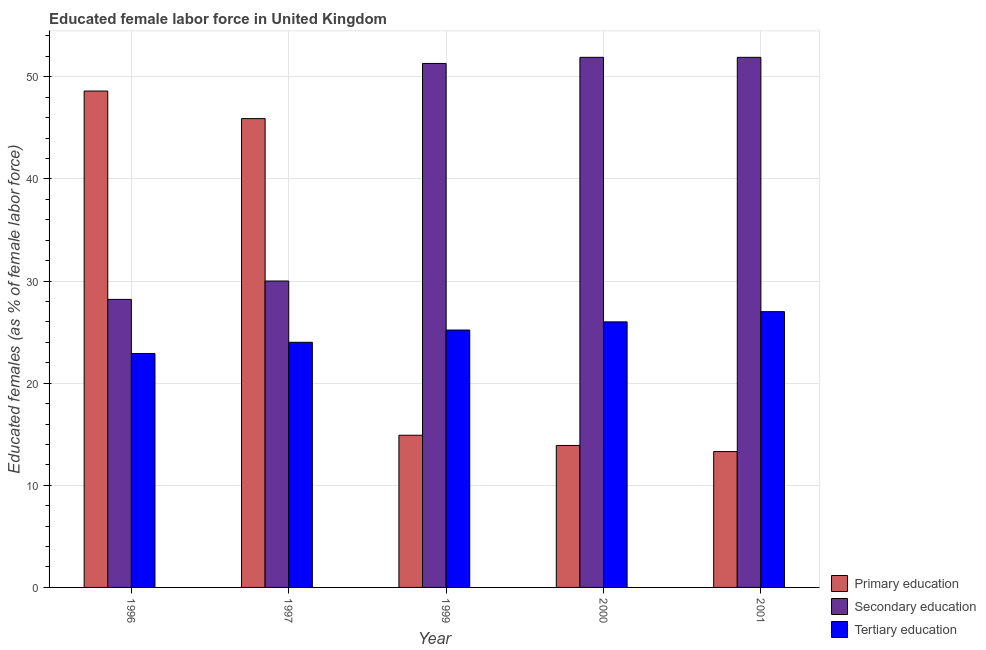Are the number of bars per tick equal to the number of legend labels?
Your answer should be compact. Yes. How many bars are there on the 4th tick from the right?
Ensure brevity in your answer.  3. In how many cases, is the number of bars for a given year not equal to the number of legend labels?
Keep it short and to the point. 0. What is the percentage of female labor force who received secondary education in 2000?
Offer a terse response. 51.9. Across all years, what is the maximum percentage of female labor force who received secondary education?
Keep it short and to the point. 51.9. Across all years, what is the minimum percentage of female labor force who received tertiary education?
Your response must be concise. 22.9. In which year was the percentage of female labor force who received tertiary education maximum?
Give a very brief answer. 2001. What is the total percentage of female labor force who received secondary education in the graph?
Give a very brief answer. 213.3. What is the difference between the percentage of female labor force who received secondary education in 1999 and that in 2000?
Your answer should be compact. -0.6. What is the difference between the percentage of female labor force who received tertiary education in 1996 and the percentage of female labor force who received primary education in 2000?
Make the answer very short. -3.1. What is the average percentage of female labor force who received primary education per year?
Offer a terse response. 27.32. In the year 1997, what is the difference between the percentage of female labor force who received secondary education and percentage of female labor force who received tertiary education?
Your response must be concise. 0. In how many years, is the percentage of female labor force who received primary education greater than 16 %?
Offer a very short reply. 2. What is the ratio of the percentage of female labor force who received tertiary education in 1997 to that in 1999?
Provide a succinct answer. 0.95. Is the percentage of female labor force who received primary education in 2000 less than that in 2001?
Ensure brevity in your answer.  No. What is the difference between the highest and the second highest percentage of female labor force who received secondary education?
Provide a succinct answer. 0. What is the difference between the highest and the lowest percentage of female labor force who received primary education?
Offer a terse response. 35.3. What does the 2nd bar from the left in 2000 represents?
Your answer should be compact. Secondary education. What does the 2nd bar from the right in 2000 represents?
Your answer should be compact. Secondary education. What is the difference between two consecutive major ticks on the Y-axis?
Your answer should be compact. 10. Are the values on the major ticks of Y-axis written in scientific E-notation?
Make the answer very short. No. Does the graph contain grids?
Provide a succinct answer. Yes. How many legend labels are there?
Give a very brief answer. 3. How are the legend labels stacked?
Offer a very short reply. Vertical. What is the title of the graph?
Give a very brief answer. Educated female labor force in United Kingdom. Does "Errors" appear as one of the legend labels in the graph?
Keep it short and to the point. No. What is the label or title of the X-axis?
Provide a short and direct response. Year. What is the label or title of the Y-axis?
Ensure brevity in your answer.  Educated females (as % of female labor force). What is the Educated females (as % of female labor force) in Primary education in 1996?
Offer a terse response. 48.6. What is the Educated females (as % of female labor force) in Secondary education in 1996?
Provide a short and direct response. 28.2. What is the Educated females (as % of female labor force) in Tertiary education in 1996?
Make the answer very short. 22.9. What is the Educated females (as % of female labor force) in Primary education in 1997?
Offer a terse response. 45.9. What is the Educated females (as % of female labor force) in Secondary education in 1997?
Ensure brevity in your answer.  30. What is the Educated females (as % of female labor force) in Primary education in 1999?
Make the answer very short. 14.9. What is the Educated females (as % of female labor force) in Secondary education in 1999?
Make the answer very short. 51.3. What is the Educated females (as % of female labor force) of Tertiary education in 1999?
Ensure brevity in your answer.  25.2. What is the Educated females (as % of female labor force) in Primary education in 2000?
Give a very brief answer. 13.9. What is the Educated females (as % of female labor force) in Secondary education in 2000?
Your answer should be very brief. 51.9. What is the Educated females (as % of female labor force) in Tertiary education in 2000?
Keep it short and to the point. 26. What is the Educated females (as % of female labor force) in Primary education in 2001?
Provide a succinct answer. 13.3. What is the Educated females (as % of female labor force) of Secondary education in 2001?
Your answer should be very brief. 51.9. Across all years, what is the maximum Educated females (as % of female labor force) in Primary education?
Make the answer very short. 48.6. Across all years, what is the maximum Educated females (as % of female labor force) of Secondary education?
Ensure brevity in your answer.  51.9. Across all years, what is the maximum Educated females (as % of female labor force) of Tertiary education?
Ensure brevity in your answer.  27. Across all years, what is the minimum Educated females (as % of female labor force) in Primary education?
Ensure brevity in your answer.  13.3. Across all years, what is the minimum Educated females (as % of female labor force) in Secondary education?
Provide a short and direct response. 28.2. Across all years, what is the minimum Educated females (as % of female labor force) in Tertiary education?
Provide a succinct answer. 22.9. What is the total Educated females (as % of female labor force) of Primary education in the graph?
Offer a terse response. 136.6. What is the total Educated females (as % of female labor force) in Secondary education in the graph?
Your answer should be compact. 213.3. What is the total Educated females (as % of female labor force) of Tertiary education in the graph?
Offer a terse response. 125.1. What is the difference between the Educated females (as % of female labor force) in Tertiary education in 1996 and that in 1997?
Offer a very short reply. -1.1. What is the difference between the Educated females (as % of female labor force) of Primary education in 1996 and that in 1999?
Offer a terse response. 33.7. What is the difference between the Educated females (as % of female labor force) of Secondary education in 1996 and that in 1999?
Make the answer very short. -23.1. What is the difference between the Educated females (as % of female labor force) of Primary education in 1996 and that in 2000?
Give a very brief answer. 34.7. What is the difference between the Educated females (as % of female labor force) in Secondary education in 1996 and that in 2000?
Offer a terse response. -23.7. What is the difference between the Educated females (as % of female labor force) of Tertiary education in 1996 and that in 2000?
Keep it short and to the point. -3.1. What is the difference between the Educated females (as % of female labor force) of Primary education in 1996 and that in 2001?
Your answer should be very brief. 35.3. What is the difference between the Educated females (as % of female labor force) of Secondary education in 1996 and that in 2001?
Keep it short and to the point. -23.7. What is the difference between the Educated females (as % of female labor force) of Tertiary education in 1996 and that in 2001?
Offer a very short reply. -4.1. What is the difference between the Educated females (as % of female labor force) of Secondary education in 1997 and that in 1999?
Make the answer very short. -21.3. What is the difference between the Educated females (as % of female labor force) of Primary education in 1997 and that in 2000?
Provide a short and direct response. 32. What is the difference between the Educated females (as % of female labor force) in Secondary education in 1997 and that in 2000?
Your answer should be very brief. -21.9. What is the difference between the Educated females (as % of female labor force) in Tertiary education in 1997 and that in 2000?
Ensure brevity in your answer.  -2. What is the difference between the Educated females (as % of female labor force) in Primary education in 1997 and that in 2001?
Provide a short and direct response. 32.6. What is the difference between the Educated females (as % of female labor force) in Secondary education in 1997 and that in 2001?
Ensure brevity in your answer.  -21.9. What is the difference between the Educated females (as % of female labor force) in Primary education in 1999 and that in 2000?
Keep it short and to the point. 1. What is the difference between the Educated females (as % of female labor force) of Secondary education in 1999 and that in 2000?
Your answer should be compact. -0.6. What is the difference between the Educated females (as % of female labor force) in Tertiary education in 1999 and that in 2000?
Give a very brief answer. -0.8. What is the difference between the Educated females (as % of female labor force) of Primary education in 1999 and that in 2001?
Give a very brief answer. 1.6. What is the difference between the Educated females (as % of female labor force) in Tertiary education in 1999 and that in 2001?
Provide a succinct answer. -1.8. What is the difference between the Educated females (as % of female labor force) in Primary education in 2000 and that in 2001?
Provide a succinct answer. 0.6. What is the difference between the Educated females (as % of female labor force) of Tertiary education in 2000 and that in 2001?
Provide a succinct answer. -1. What is the difference between the Educated females (as % of female labor force) of Primary education in 1996 and the Educated females (as % of female labor force) of Secondary education in 1997?
Provide a short and direct response. 18.6. What is the difference between the Educated females (as % of female labor force) of Primary education in 1996 and the Educated females (as % of female labor force) of Tertiary education in 1997?
Keep it short and to the point. 24.6. What is the difference between the Educated females (as % of female labor force) in Secondary education in 1996 and the Educated females (as % of female labor force) in Tertiary education in 1997?
Give a very brief answer. 4.2. What is the difference between the Educated females (as % of female labor force) in Primary education in 1996 and the Educated females (as % of female labor force) in Tertiary education in 1999?
Give a very brief answer. 23.4. What is the difference between the Educated females (as % of female labor force) in Secondary education in 1996 and the Educated females (as % of female labor force) in Tertiary education in 1999?
Offer a terse response. 3. What is the difference between the Educated females (as % of female labor force) of Primary education in 1996 and the Educated females (as % of female labor force) of Secondary education in 2000?
Provide a succinct answer. -3.3. What is the difference between the Educated females (as % of female labor force) in Primary education in 1996 and the Educated females (as % of female labor force) in Tertiary education in 2000?
Your response must be concise. 22.6. What is the difference between the Educated females (as % of female labor force) of Secondary education in 1996 and the Educated females (as % of female labor force) of Tertiary education in 2000?
Offer a very short reply. 2.2. What is the difference between the Educated females (as % of female labor force) in Primary education in 1996 and the Educated females (as % of female labor force) in Secondary education in 2001?
Your response must be concise. -3.3. What is the difference between the Educated females (as % of female labor force) in Primary education in 1996 and the Educated females (as % of female labor force) in Tertiary education in 2001?
Your answer should be compact. 21.6. What is the difference between the Educated females (as % of female labor force) in Secondary education in 1996 and the Educated females (as % of female labor force) in Tertiary education in 2001?
Ensure brevity in your answer.  1.2. What is the difference between the Educated females (as % of female labor force) of Primary education in 1997 and the Educated females (as % of female labor force) of Secondary education in 1999?
Provide a succinct answer. -5.4. What is the difference between the Educated females (as % of female labor force) in Primary education in 1997 and the Educated females (as % of female labor force) in Tertiary education in 1999?
Provide a short and direct response. 20.7. What is the difference between the Educated females (as % of female labor force) in Secondary education in 1997 and the Educated females (as % of female labor force) in Tertiary education in 2001?
Offer a very short reply. 3. What is the difference between the Educated females (as % of female labor force) in Primary education in 1999 and the Educated females (as % of female labor force) in Secondary education in 2000?
Give a very brief answer. -37. What is the difference between the Educated females (as % of female labor force) in Primary education in 1999 and the Educated females (as % of female labor force) in Tertiary education in 2000?
Provide a succinct answer. -11.1. What is the difference between the Educated females (as % of female labor force) of Secondary education in 1999 and the Educated females (as % of female labor force) of Tertiary education in 2000?
Your response must be concise. 25.3. What is the difference between the Educated females (as % of female labor force) in Primary education in 1999 and the Educated females (as % of female labor force) in Secondary education in 2001?
Your answer should be compact. -37. What is the difference between the Educated females (as % of female labor force) of Secondary education in 1999 and the Educated females (as % of female labor force) of Tertiary education in 2001?
Provide a short and direct response. 24.3. What is the difference between the Educated females (as % of female labor force) in Primary education in 2000 and the Educated females (as % of female labor force) in Secondary education in 2001?
Provide a succinct answer. -38. What is the difference between the Educated females (as % of female labor force) of Secondary education in 2000 and the Educated females (as % of female labor force) of Tertiary education in 2001?
Make the answer very short. 24.9. What is the average Educated females (as % of female labor force) of Primary education per year?
Offer a terse response. 27.32. What is the average Educated females (as % of female labor force) in Secondary education per year?
Provide a short and direct response. 42.66. What is the average Educated females (as % of female labor force) in Tertiary education per year?
Your answer should be compact. 25.02. In the year 1996, what is the difference between the Educated females (as % of female labor force) in Primary education and Educated females (as % of female labor force) in Secondary education?
Your response must be concise. 20.4. In the year 1996, what is the difference between the Educated females (as % of female labor force) of Primary education and Educated females (as % of female labor force) of Tertiary education?
Your response must be concise. 25.7. In the year 1997, what is the difference between the Educated females (as % of female labor force) in Primary education and Educated females (as % of female labor force) in Secondary education?
Provide a succinct answer. 15.9. In the year 1997, what is the difference between the Educated females (as % of female labor force) in Primary education and Educated females (as % of female labor force) in Tertiary education?
Your answer should be very brief. 21.9. In the year 1999, what is the difference between the Educated females (as % of female labor force) in Primary education and Educated females (as % of female labor force) in Secondary education?
Ensure brevity in your answer.  -36.4. In the year 1999, what is the difference between the Educated females (as % of female labor force) in Secondary education and Educated females (as % of female labor force) in Tertiary education?
Provide a succinct answer. 26.1. In the year 2000, what is the difference between the Educated females (as % of female labor force) in Primary education and Educated females (as % of female labor force) in Secondary education?
Provide a succinct answer. -38. In the year 2000, what is the difference between the Educated females (as % of female labor force) in Secondary education and Educated females (as % of female labor force) in Tertiary education?
Keep it short and to the point. 25.9. In the year 2001, what is the difference between the Educated females (as % of female labor force) of Primary education and Educated females (as % of female labor force) of Secondary education?
Your response must be concise. -38.6. In the year 2001, what is the difference between the Educated females (as % of female labor force) of Primary education and Educated females (as % of female labor force) of Tertiary education?
Your answer should be very brief. -13.7. In the year 2001, what is the difference between the Educated females (as % of female labor force) of Secondary education and Educated females (as % of female labor force) of Tertiary education?
Offer a very short reply. 24.9. What is the ratio of the Educated females (as % of female labor force) in Primary education in 1996 to that in 1997?
Offer a very short reply. 1.06. What is the ratio of the Educated females (as % of female labor force) of Tertiary education in 1996 to that in 1997?
Provide a short and direct response. 0.95. What is the ratio of the Educated females (as % of female labor force) of Primary education in 1996 to that in 1999?
Ensure brevity in your answer.  3.26. What is the ratio of the Educated females (as % of female labor force) in Secondary education in 1996 to that in 1999?
Your answer should be very brief. 0.55. What is the ratio of the Educated females (as % of female labor force) in Tertiary education in 1996 to that in 1999?
Your answer should be very brief. 0.91. What is the ratio of the Educated females (as % of female labor force) of Primary education in 1996 to that in 2000?
Provide a succinct answer. 3.5. What is the ratio of the Educated females (as % of female labor force) in Secondary education in 1996 to that in 2000?
Your response must be concise. 0.54. What is the ratio of the Educated females (as % of female labor force) of Tertiary education in 1996 to that in 2000?
Ensure brevity in your answer.  0.88. What is the ratio of the Educated females (as % of female labor force) in Primary education in 1996 to that in 2001?
Your response must be concise. 3.65. What is the ratio of the Educated females (as % of female labor force) in Secondary education in 1996 to that in 2001?
Offer a terse response. 0.54. What is the ratio of the Educated females (as % of female labor force) of Tertiary education in 1996 to that in 2001?
Make the answer very short. 0.85. What is the ratio of the Educated females (as % of female labor force) of Primary education in 1997 to that in 1999?
Provide a succinct answer. 3.08. What is the ratio of the Educated females (as % of female labor force) of Secondary education in 1997 to that in 1999?
Make the answer very short. 0.58. What is the ratio of the Educated females (as % of female labor force) in Tertiary education in 1997 to that in 1999?
Your answer should be compact. 0.95. What is the ratio of the Educated females (as % of female labor force) in Primary education in 1997 to that in 2000?
Provide a succinct answer. 3.3. What is the ratio of the Educated females (as % of female labor force) of Secondary education in 1997 to that in 2000?
Your response must be concise. 0.58. What is the ratio of the Educated females (as % of female labor force) of Primary education in 1997 to that in 2001?
Provide a succinct answer. 3.45. What is the ratio of the Educated females (as % of female labor force) of Secondary education in 1997 to that in 2001?
Keep it short and to the point. 0.58. What is the ratio of the Educated females (as % of female labor force) in Tertiary education in 1997 to that in 2001?
Your response must be concise. 0.89. What is the ratio of the Educated females (as % of female labor force) in Primary education in 1999 to that in 2000?
Your answer should be very brief. 1.07. What is the ratio of the Educated females (as % of female labor force) in Secondary education in 1999 to that in 2000?
Offer a very short reply. 0.99. What is the ratio of the Educated females (as % of female labor force) of Tertiary education in 1999 to that in 2000?
Your answer should be compact. 0.97. What is the ratio of the Educated females (as % of female labor force) in Primary education in 1999 to that in 2001?
Make the answer very short. 1.12. What is the ratio of the Educated females (as % of female labor force) in Secondary education in 1999 to that in 2001?
Provide a short and direct response. 0.99. What is the ratio of the Educated females (as % of female labor force) in Primary education in 2000 to that in 2001?
Offer a very short reply. 1.05. What is the difference between the highest and the second highest Educated females (as % of female labor force) of Secondary education?
Make the answer very short. 0. What is the difference between the highest and the lowest Educated females (as % of female labor force) of Primary education?
Offer a terse response. 35.3. What is the difference between the highest and the lowest Educated females (as % of female labor force) in Secondary education?
Offer a terse response. 23.7. 